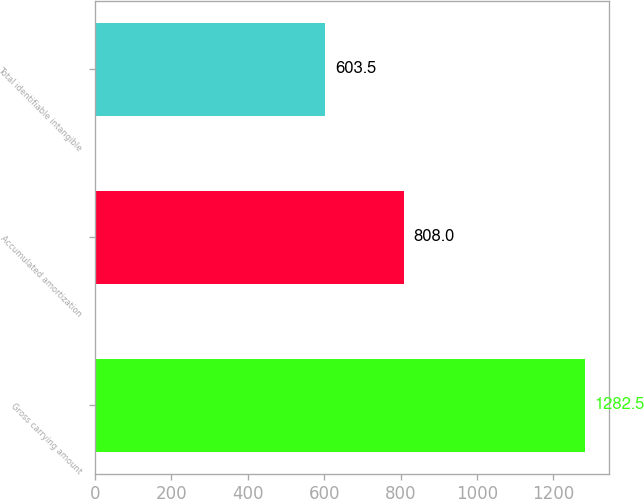Convert chart to OTSL. <chart><loc_0><loc_0><loc_500><loc_500><bar_chart><fcel>Gross carrying amount<fcel>Accumulated amortization<fcel>Total identifiable intangible<nl><fcel>1282.5<fcel>808<fcel>603.5<nl></chart> 